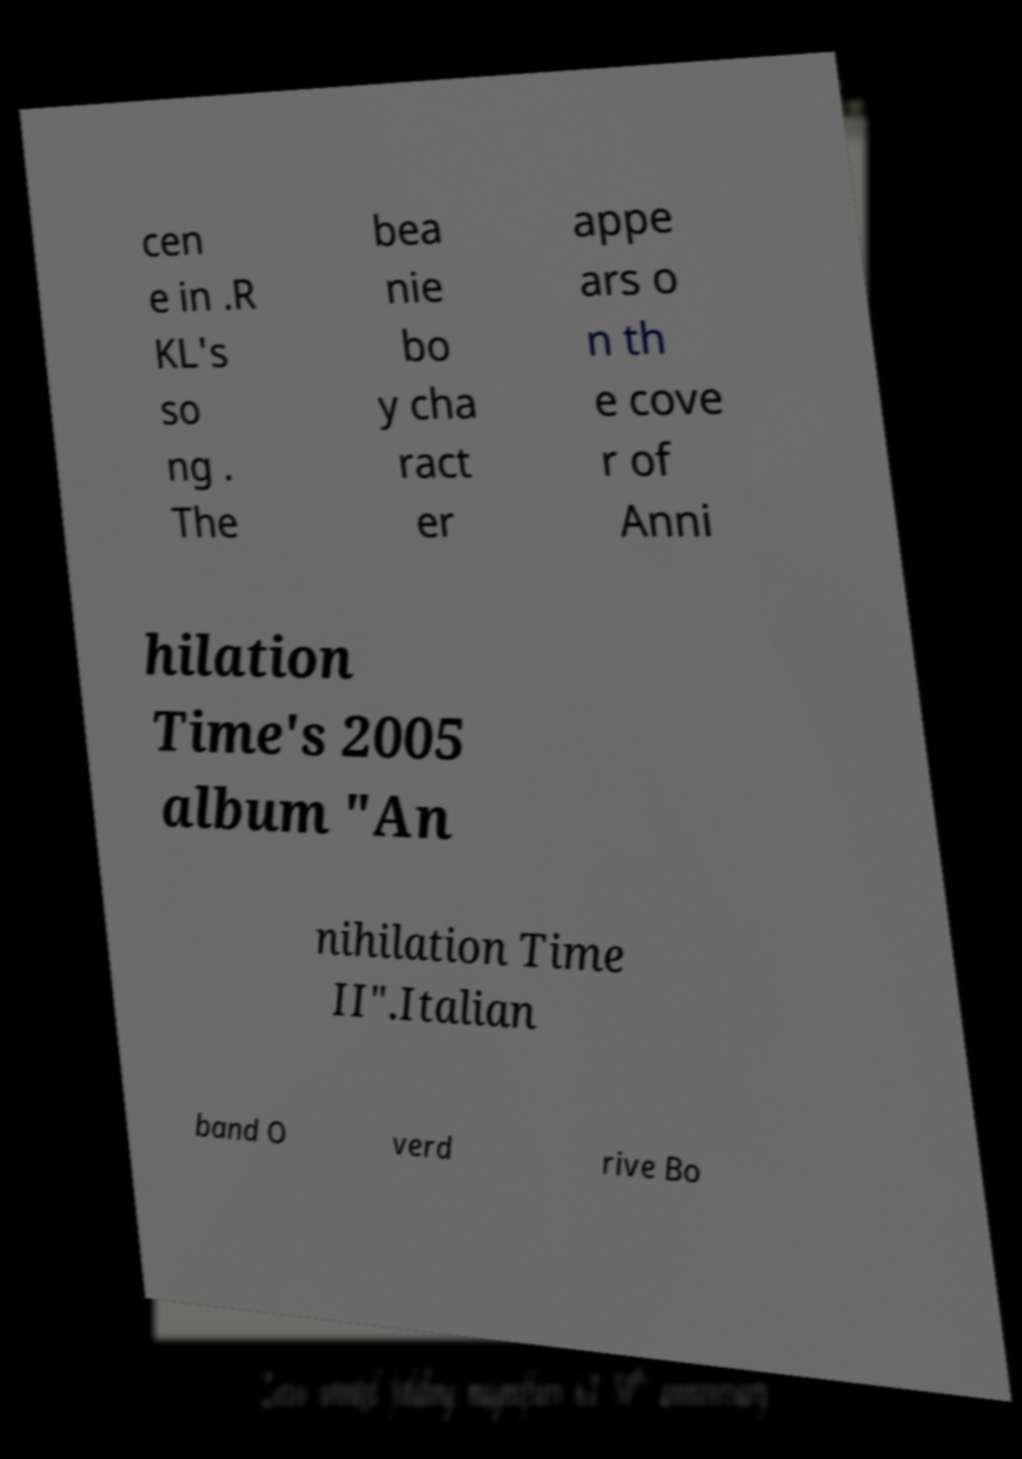Could you assist in decoding the text presented in this image and type it out clearly? cen e in .R KL's so ng . The bea nie bo y cha ract er appe ars o n th e cove r of Anni hilation Time's 2005 album "An nihilation Time II".Italian band O verd rive Bo 